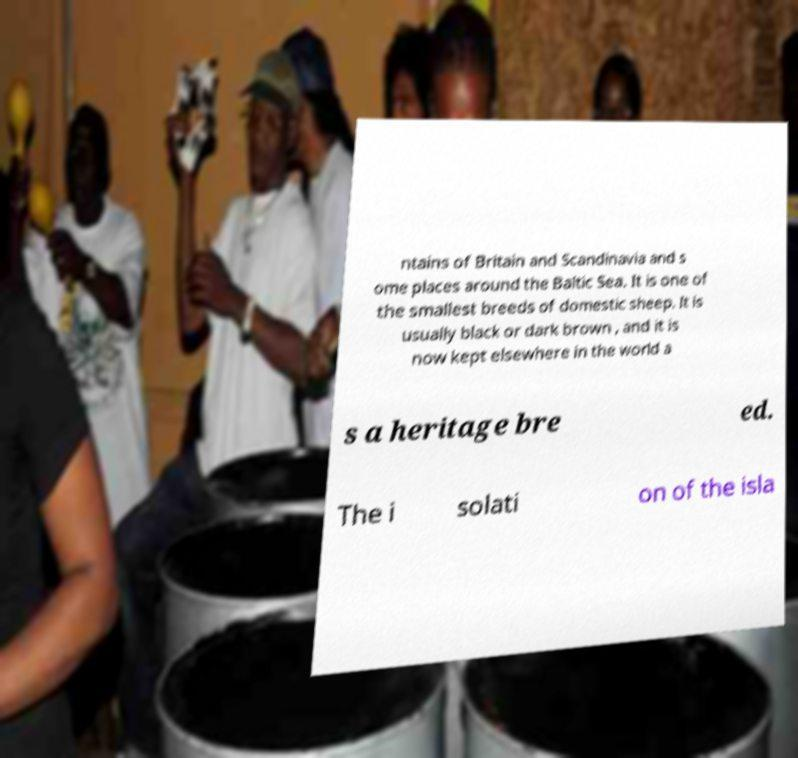Can you accurately transcribe the text from the provided image for me? ntains of Britain and Scandinavia and s ome places around the Baltic Sea. It is one of the smallest breeds of domestic sheep. It is usually black or dark brown , and it is now kept elsewhere in the world a s a heritage bre ed. The i solati on of the isla 